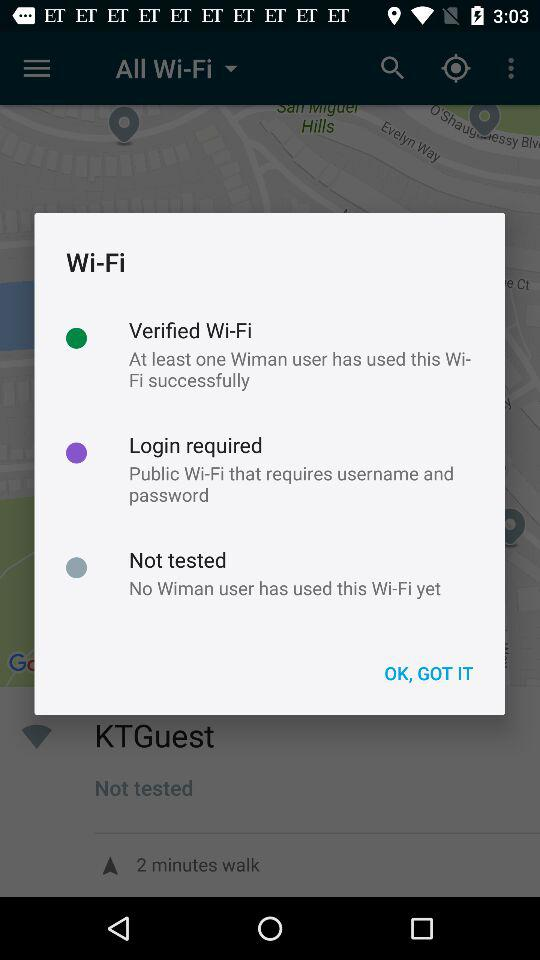How many Wi-Fi types are there?
Answer the question using a single word or phrase. 3 